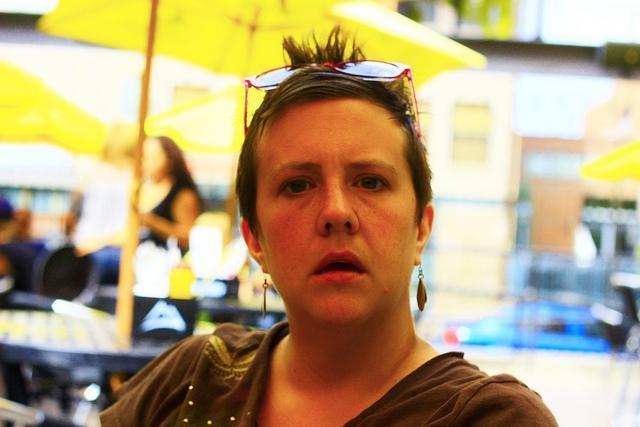How many people are visible?
Give a very brief answer. 3. How many umbrellas can you see?
Give a very brief answer. 2. 